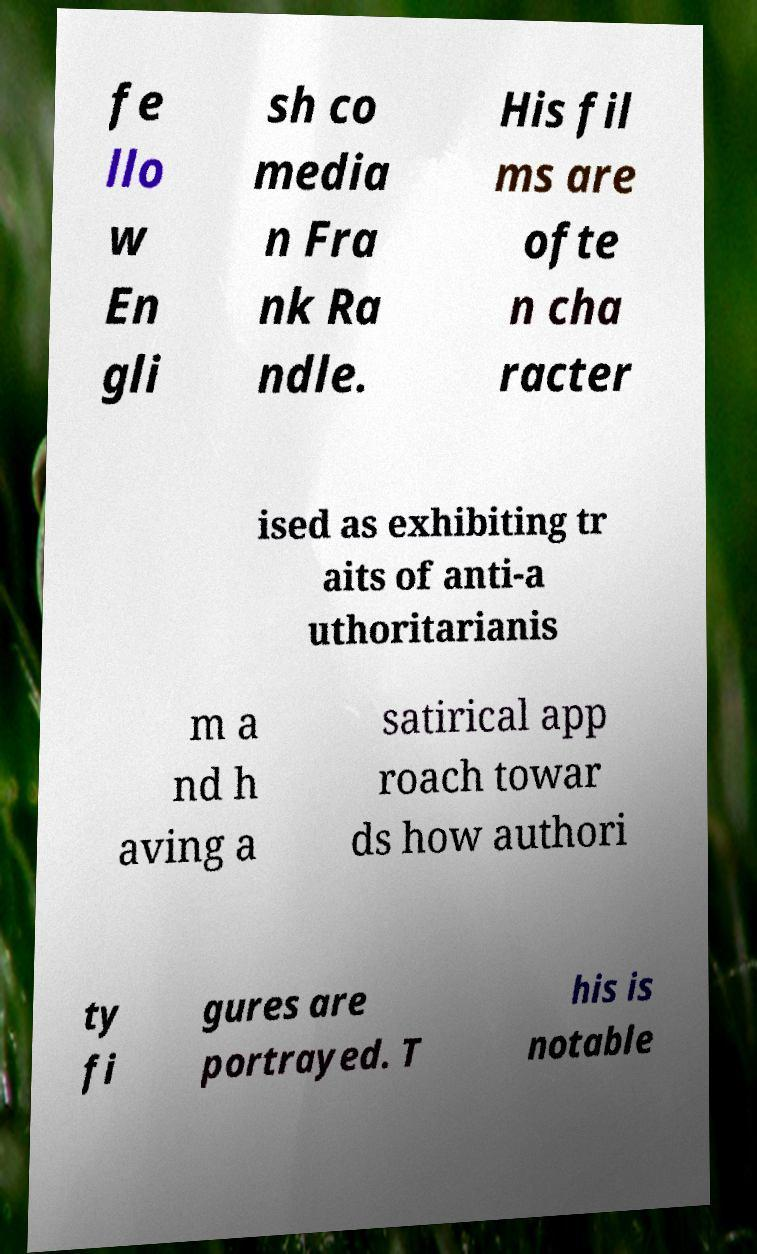Please read and relay the text visible in this image. What does it say? fe llo w En gli sh co media n Fra nk Ra ndle. His fil ms are ofte n cha racter ised as exhibiting tr aits of anti-a uthoritarianis m a nd h aving a satirical app roach towar ds how authori ty fi gures are portrayed. T his is notable 